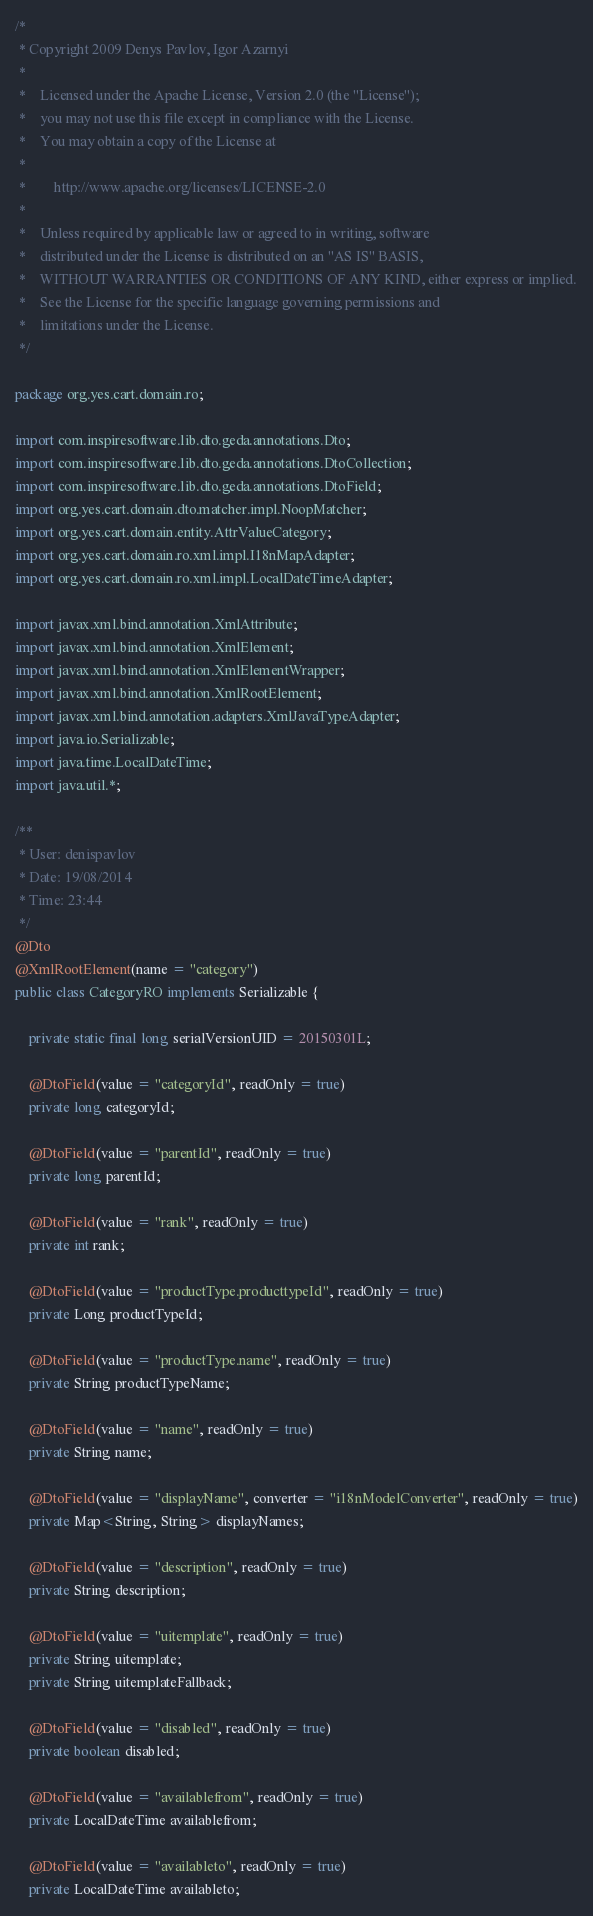Convert code to text. <code><loc_0><loc_0><loc_500><loc_500><_Java_>/*
 * Copyright 2009 Denys Pavlov, Igor Azarnyi
 *
 *    Licensed under the Apache License, Version 2.0 (the "License");
 *    you may not use this file except in compliance with the License.
 *    You may obtain a copy of the License at
 *
 *        http://www.apache.org/licenses/LICENSE-2.0
 *
 *    Unless required by applicable law or agreed to in writing, software
 *    distributed under the License is distributed on an "AS IS" BASIS,
 *    WITHOUT WARRANTIES OR CONDITIONS OF ANY KIND, either express or implied.
 *    See the License for the specific language governing permissions and
 *    limitations under the License.
 */

package org.yes.cart.domain.ro;

import com.inspiresoftware.lib.dto.geda.annotations.Dto;
import com.inspiresoftware.lib.dto.geda.annotations.DtoCollection;
import com.inspiresoftware.lib.dto.geda.annotations.DtoField;
import org.yes.cart.domain.dto.matcher.impl.NoopMatcher;
import org.yes.cart.domain.entity.AttrValueCategory;
import org.yes.cart.domain.ro.xml.impl.I18nMapAdapter;
import org.yes.cart.domain.ro.xml.impl.LocalDateTimeAdapter;

import javax.xml.bind.annotation.XmlAttribute;
import javax.xml.bind.annotation.XmlElement;
import javax.xml.bind.annotation.XmlElementWrapper;
import javax.xml.bind.annotation.XmlRootElement;
import javax.xml.bind.annotation.adapters.XmlJavaTypeAdapter;
import java.io.Serializable;
import java.time.LocalDateTime;
import java.util.*;

/**
 * User: denispavlov
 * Date: 19/08/2014
 * Time: 23:44
 */
@Dto
@XmlRootElement(name = "category")
public class CategoryRO implements Serializable {

    private static final long serialVersionUID = 20150301L;

    @DtoField(value = "categoryId", readOnly = true)
    private long categoryId;

    @DtoField(value = "parentId", readOnly = true)
    private long parentId;

    @DtoField(value = "rank", readOnly = true)
    private int rank;

    @DtoField(value = "productType.producttypeId", readOnly = true)
    private Long productTypeId;

    @DtoField(value = "productType.name", readOnly = true)
    private String productTypeName;

    @DtoField(value = "name", readOnly = true)
    private String name;

    @DtoField(value = "displayName", converter = "i18nModelConverter", readOnly = true)
    private Map<String, String> displayNames;

    @DtoField(value = "description", readOnly = true)
    private String description;

    @DtoField(value = "uitemplate", readOnly = true)
    private String uitemplate;
    private String uitemplateFallback;

    @DtoField(value = "disabled", readOnly = true)
    private boolean disabled;

    @DtoField(value = "availablefrom", readOnly = true)
    private LocalDateTime availablefrom;

    @DtoField(value = "availableto", readOnly = true)
    private LocalDateTime availableto;
</code> 